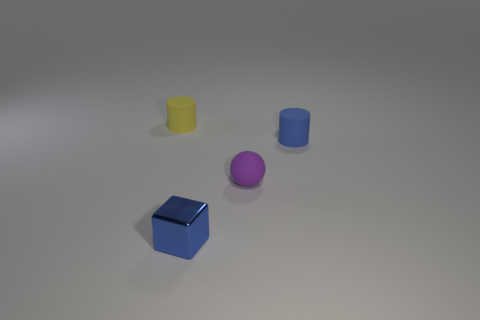Add 2 tiny brown matte spheres. How many objects exist? 6 Subtract all balls. How many objects are left? 3 Subtract 0 red balls. How many objects are left? 4 Subtract all small blue blocks. Subtract all small blue shiny cubes. How many objects are left? 2 Add 2 tiny blue blocks. How many tiny blue blocks are left? 3 Add 4 small purple rubber things. How many small purple rubber things exist? 5 